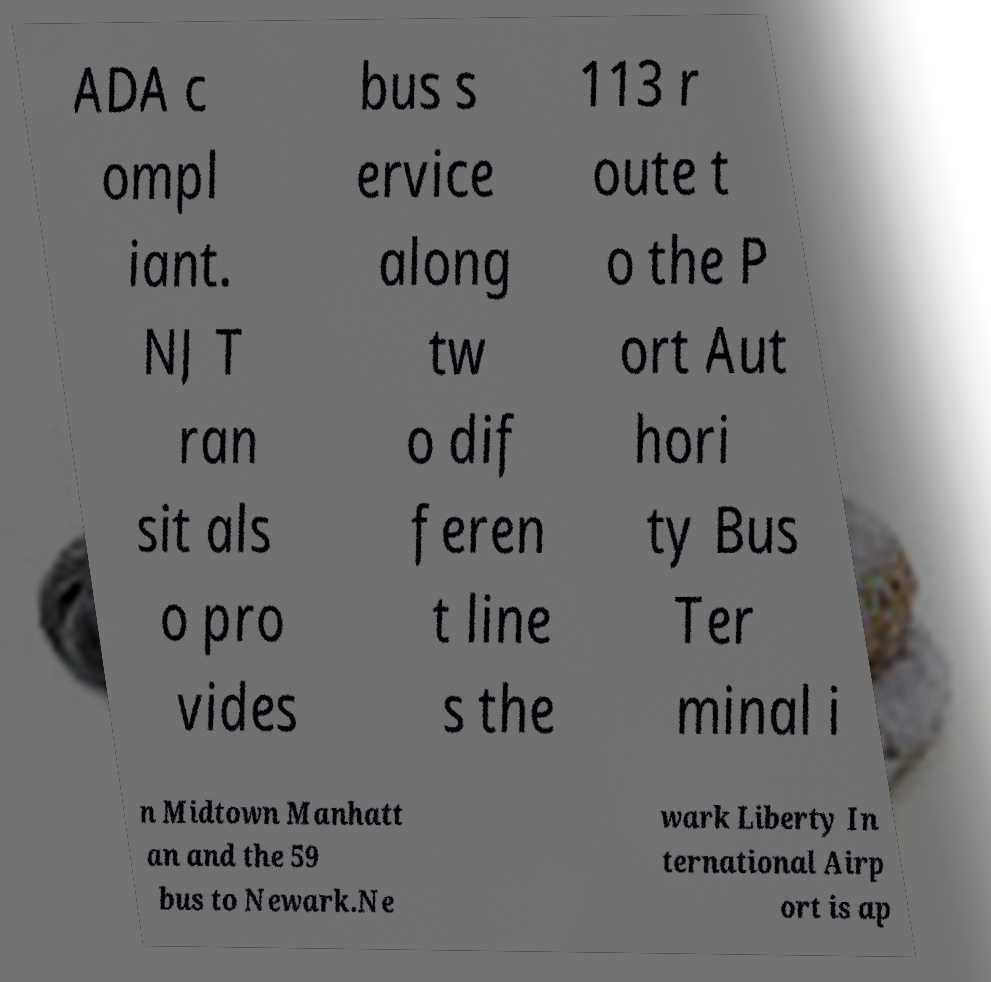Can you accurately transcribe the text from the provided image for me? ADA c ompl iant. NJ T ran sit als o pro vides bus s ervice along tw o dif feren t line s the 113 r oute t o the P ort Aut hori ty Bus Ter minal i n Midtown Manhatt an and the 59 bus to Newark.Ne wark Liberty In ternational Airp ort is ap 